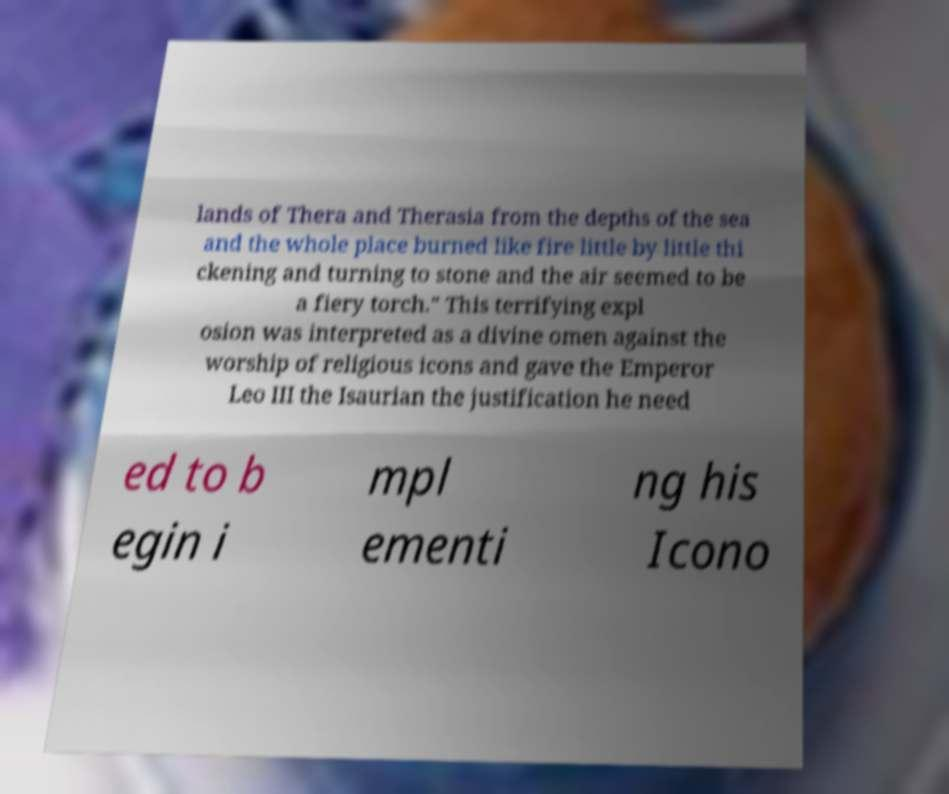I need the written content from this picture converted into text. Can you do that? lands of Thera and Therasia from the depths of the sea and the whole place burned like fire little by little thi ckening and turning to stone and the air seemed to be a fiery torch." This terrifying expl osion was interpreted as a divine omen against the worship of religious icons and gave the Emperor Leo III the Isaurian the justification he need ed to b egin i mpl ementi ng his Icono 